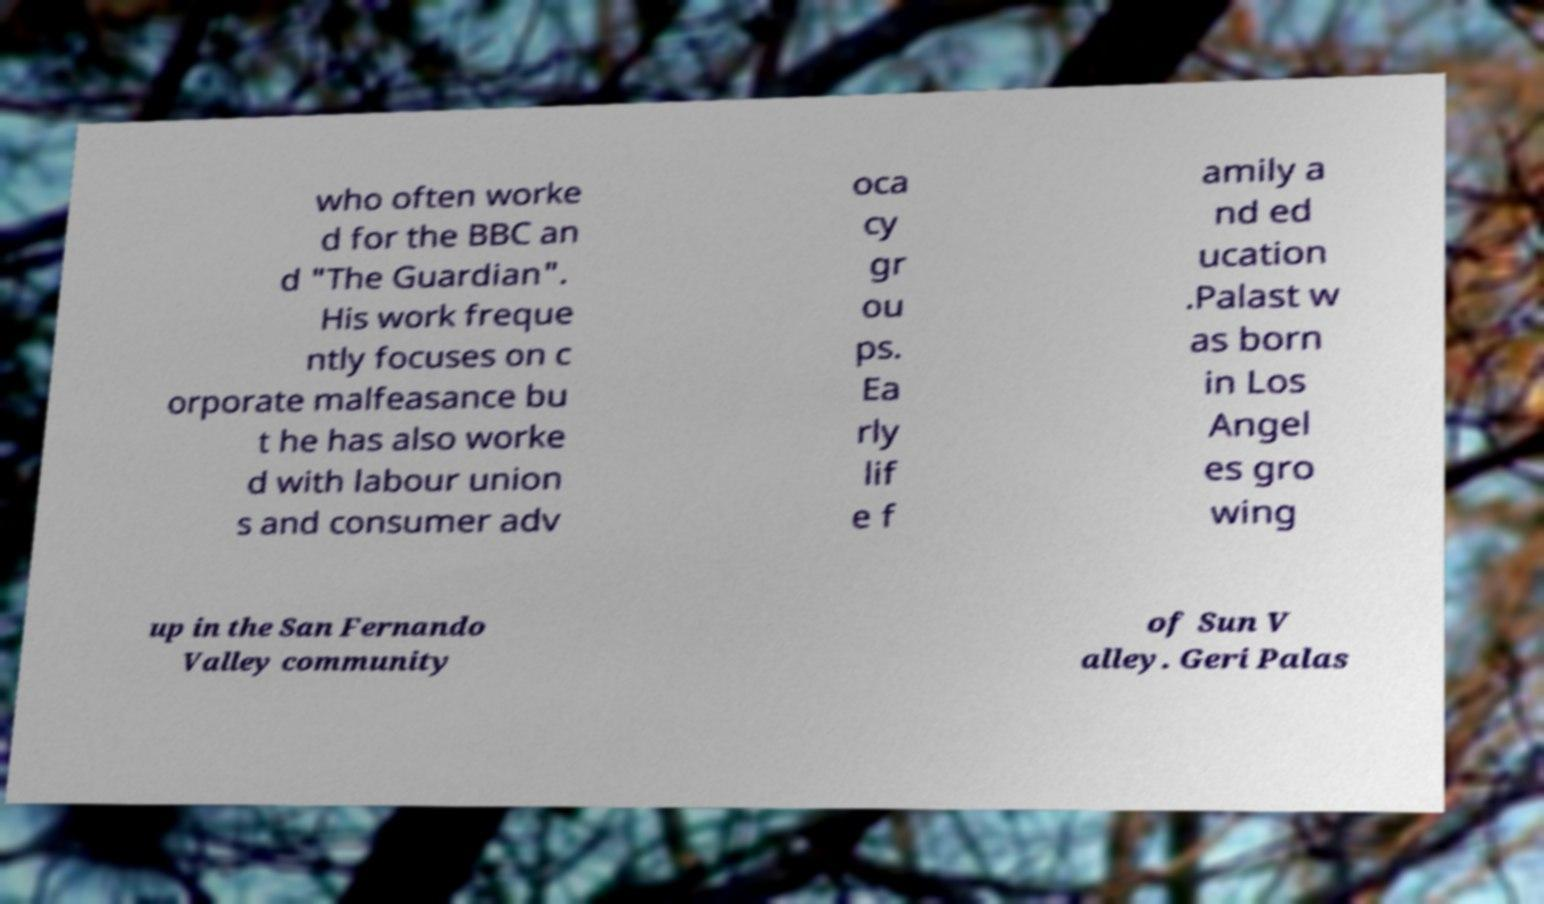Please identify and transcribe the text found in this image. who often worke d for the BBC an d "The Guardian". His work freque ntly focuses on c orporate malfeasance bu t he has also worke d with labour union s and consumer adv oca cy gr ou ps. Ea rly lif e f amily a nd ed ucation .Palast w as born in Los Angel es gro wing up in the San Fernando Valley community of Sun V alley. Geri Palas 